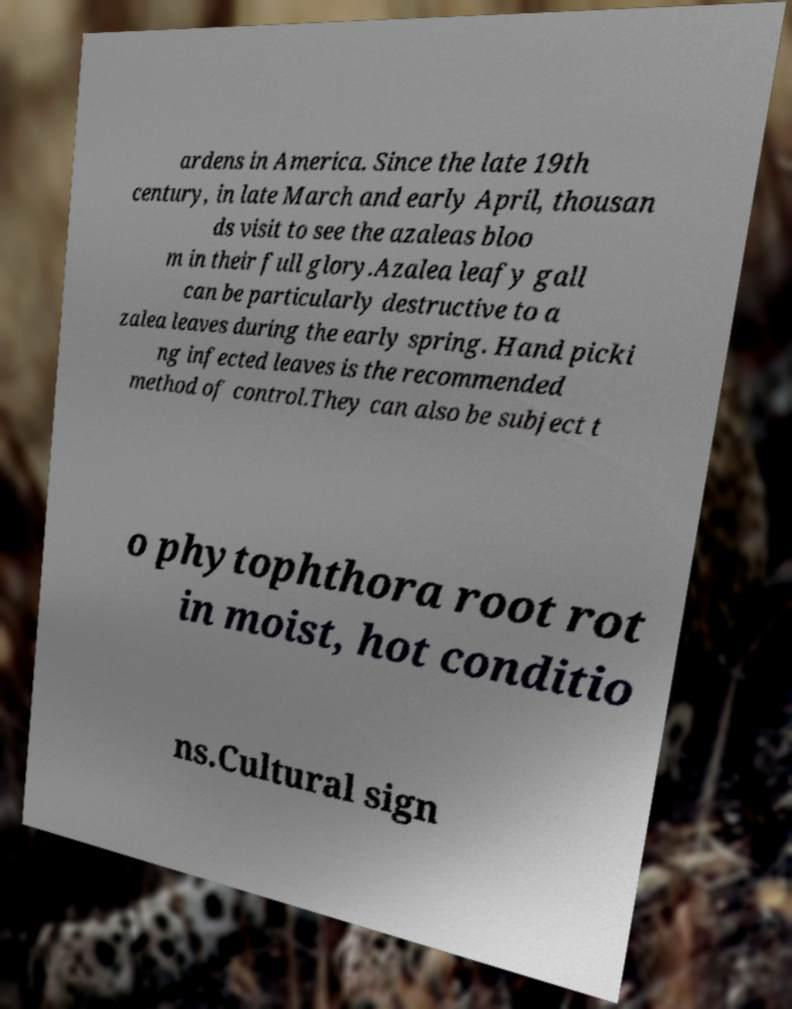There's text embedded in this image that I need extracted. Can you transcribe it verbatim? ardens in America. Since the late 19th century, in late March and early April, thousan ds visit to see the azaleas bloo m in their full glory.Azalea leafy gall can be particularly destructive to a zalea leaves during the early spring. Hand picki ng infected leaves is the recommended method of control.They can also be subject t o phytophthora root rot in moist, hot conditio ns.Cultural sign 